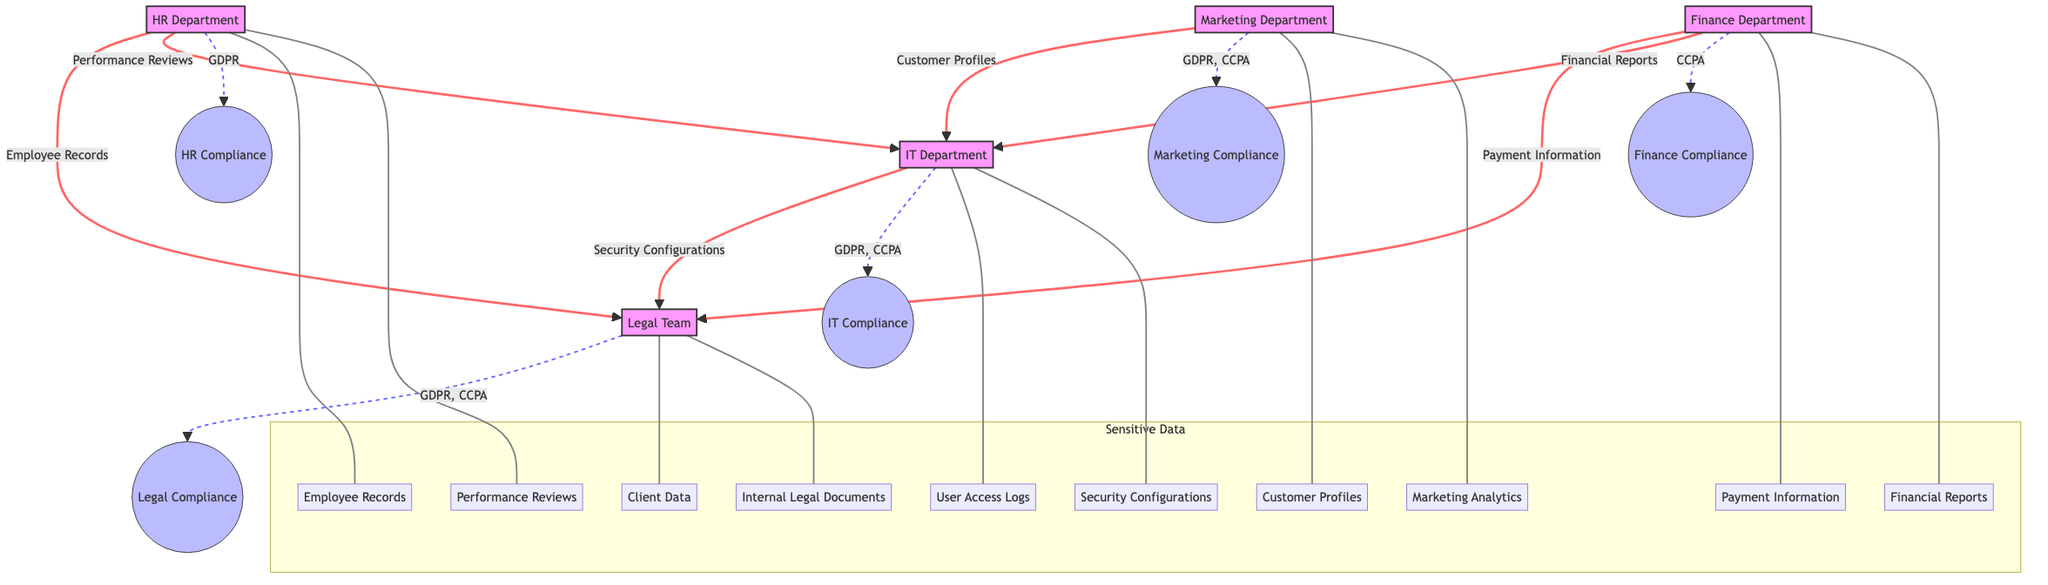What departments are involved in the data flow from HR to Legal Team? The data flow from HR to Legal Team involves the HR Department and the Legal Team as the destination of the data flow.
Answer: HR Department, Legal Team How many types of sensitive data does the IT Department handle? In the diagram, the IT Department manages two types of sensitive data: User Access Logs and Security Configurations.
Answer: 2 What is the purpose behind the data flow from Finance Department to IT Department? The purpose of the data flow from Finance Department to IT Department is to implement Cybersecurity Measures for the Financial Reports data.
Answer: Cybersecurity Measures Which compliance tasks are associated with the Marketing Department? The compliance tasks associated with the Marketing Department include Consent Management and Data Anonymization, reflecting their focus on data privacy related to marketing activities.
Answer: Consent Management, Data Anonymization Which laws are the HR Department required to comply with? The HR Department is required to comply with GDPR, as indicated by the compliance checkpoint linked to the department.
Answer: GDPR What is the flow of sensitive data from the Marketing Department and its purpose? The flow of sensitive data from the Marketing Department to the IT Department involves Customer Profiles with the purpose of Data Security Implementation.
Answer: Customer Profiles, Data Security Implementation How many departments are connected to the Legal Team through data flows? The diagram indicates that four departments (HR, Finance, IT, and Marketing) have data flows that connect to the Legal Team.
Answer: 4 Which department is responsible for handling Payment Information and its compliance tasks? The Finance Department is responsible for handling Payment Information and its compliance tasks include Data Breach Notifications and Secure Payment Processing.
Answer: Finance Department What type of data is transferred from HR to IT and for what purpose? The type of data transferred from HR to IT is Performance Reviews, for the purpose of Data Storage and Protection.
Answer: Performance Reviews, Data Storage and Protection 